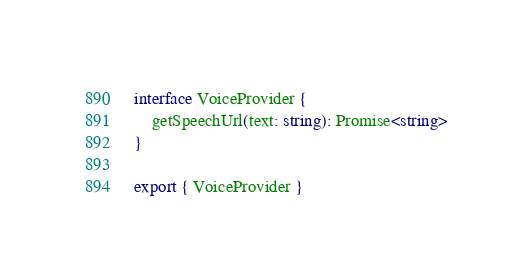Convert code to text. <code><loc_0><loc_0><loc_500><loc_500><_TypeScript_>interface VoiceProvider {
    getSpeechUrl(text: string): Promise<string>
}

export { VoiceProvider }
</code> 